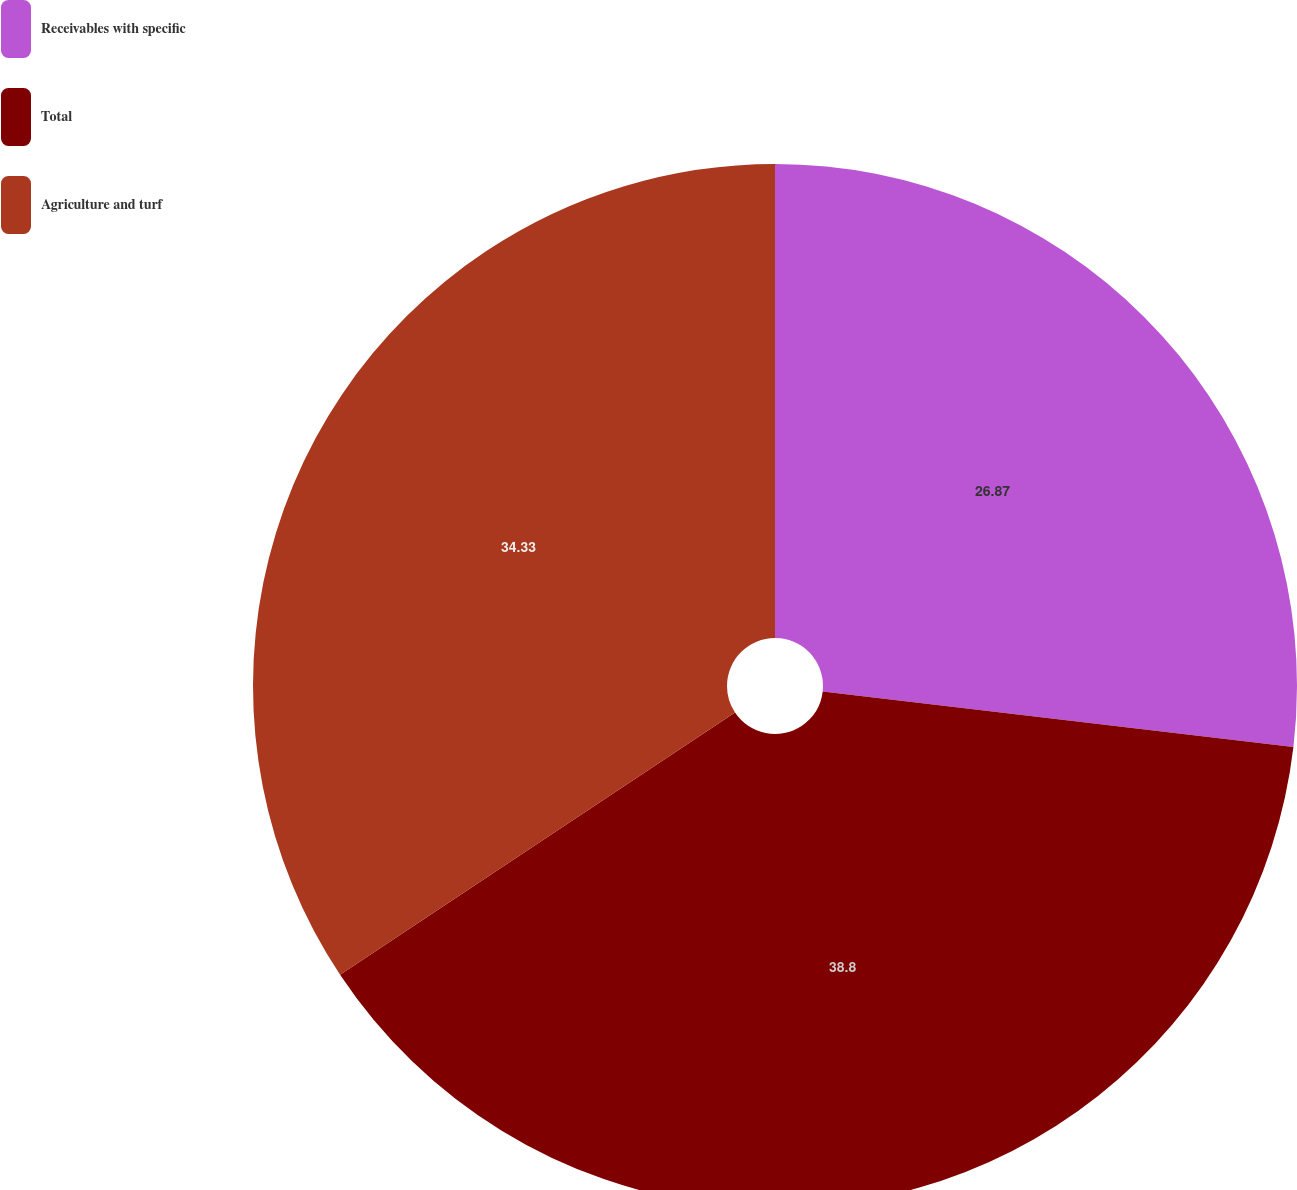<chart> <loc_0><loc_0><loc_500><loc_500><pie_chart><fcel>Receivables with specific<fcel>Total<fcel>Agriculture and turf<nl><fcel>26.87%<fcel>38.81%<fcel>34.33%<nl></chart> 